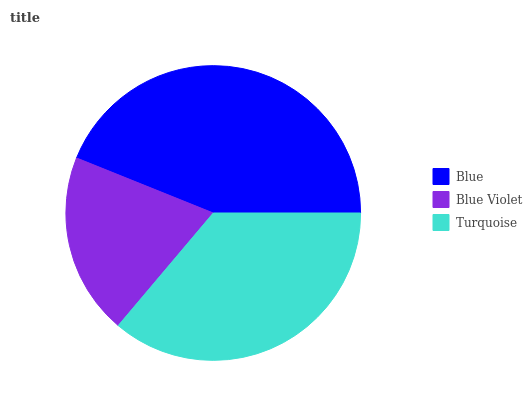Is Blue Violet the minimum?
Answer yes or no. Yes. Is Blue the maximum?
Answer yes or no. Yes. Is Turquoise the minimum?
Answer yes or no. No. Is Turquoise the maximum?
Answer yes or no. No. Is Turquoise greater than Blue Violet?
Answer yes or no. Yes. Is Blue Violet less than Turquoise?
Answer yes or no. Yes. Is Blue Violet greater than Turquoise?
Answer yes or no. No. Is Turquoise less than Blue Violet?
Answer yes or no. No. Is Turquoise the high median?
Answer yes or no. Yes. Is Turquoise the low median?
Answer yes or no. Yes. Is Blue the high median?
Answer yes or no. No. Is Blue the low median?
Answer yes or no. No. 